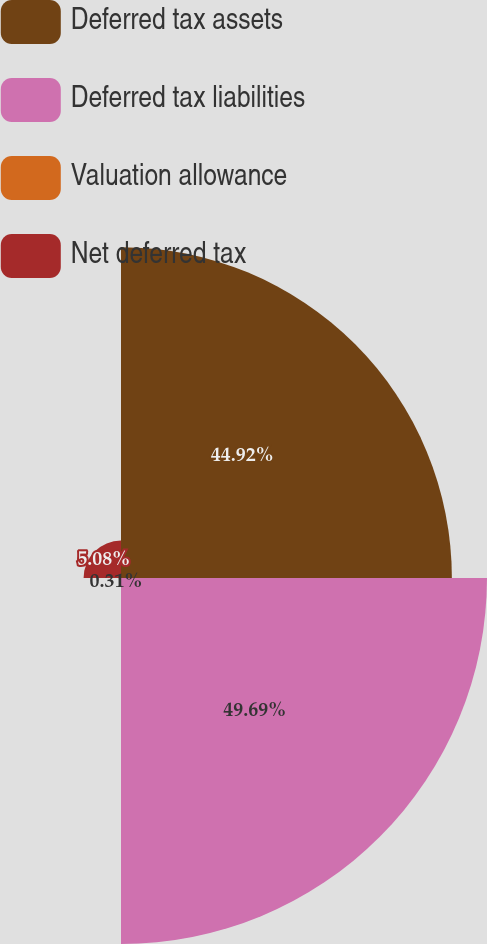Convert chart to OTSL. <chart><loc_0><loc_0><loc_500><loc_500><pie_chart><fcel>Deferred tax assets<fcel>Deferred tax liabilities<fcel>Valuation allowance<fcel>Net deferred tax<nl><fcel>44.92%<fcel>49.69%<fcel>0.31%<fcel>5.08%<nl></chart> 